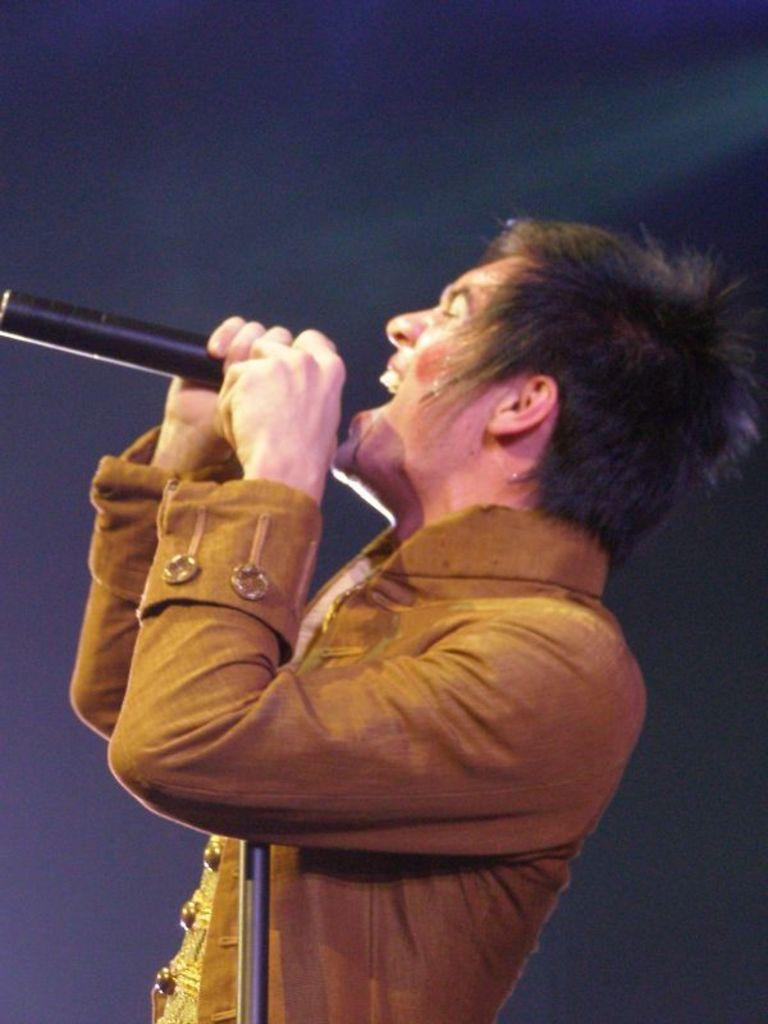What is: What is the main subject of the image? There is a person in the image. What is the person holding in the image? The person is holding a microphone. What is the person doing with the microphone? The person is singing. What can be observed about the background of the image? The background of the image is dark. What type of pie is being served on the bridge in the image? There is no pie or bridge present in the image. How does the sleet affect the person's performance in the image? There is no mention of sleet in the image, so its effect on the person's performance cannot be determined. 